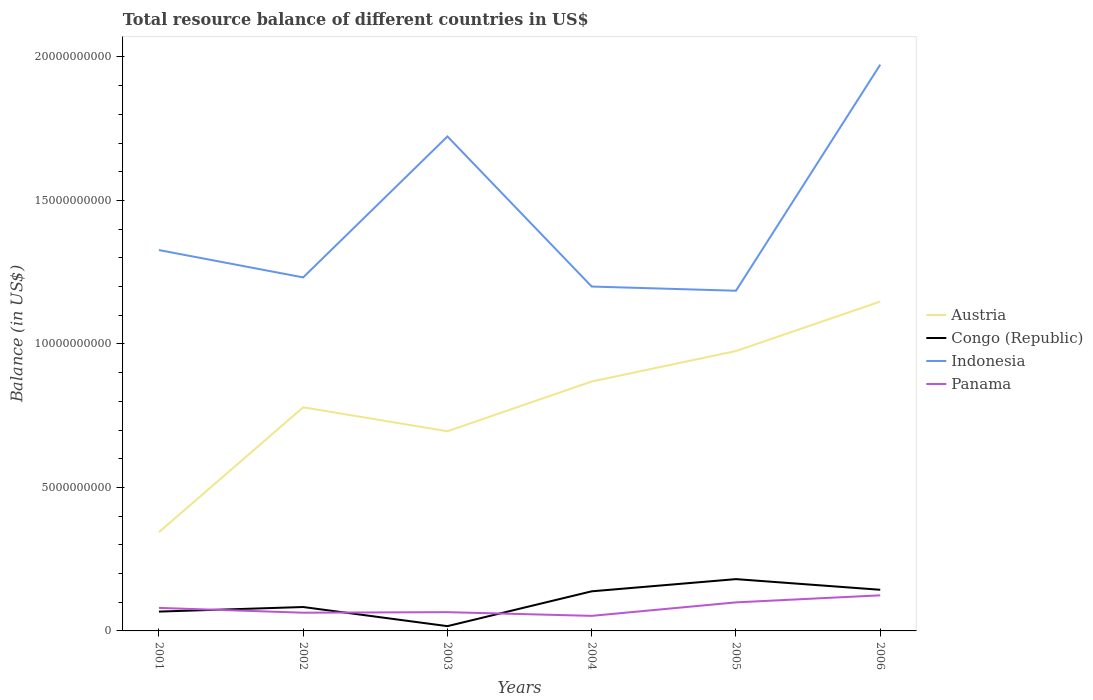Across all years, what is the maximum total resource balance in Austria?
Your answer should be very brief. 3.44e+09. In which year was the total resource balance in Austria maximum?
Your response must be concise. 2001. What is the total total resource balance in Indonesia in the graph?
Your response must be concise. -4.91e+09. What is the difference between the highest and the second highest total resource balance in Austria?
Provide a succinct answer. 8.04e+09. What is the difference between the highest and the lowest total resource balance in Congo (Republic)?
Provide a short and direct response. 3. Are the values on the major ticks of Y-axis written in scientific E-notation?
Your answer should be very brief. No. Does the graph contain any zero values?
Ensure brevity in your answer.  No. What is the title of the graph?
Your response must be concise. Total resource balance of different countries in US$. What is the label or title of the X-axis?
Your answer should be very brief. Years. What is the label or title of the Y-axis?
Give a very brief answer. Balance (in US$). What is the Balance (in US$) of Austria in 2001?
Keep it short and to the point. 3.44e+09. What is the Balance (in US$) in Congo (Republic) in 2001?
Provide a succinct answer. 6.74e+08. What is the Balance (in US$) in Indonesia in 2001?
Keep it short and to the point. 1.33e+1. What is the Balance (in US$) of Panama in 2001?
Make the answer very short. 8.03e+08. What is the Balance (in US$) in Austria in 2002?
Provide a succinct answer. 7.79e+09. What is the Balance (in US$) of Congo (Republic) in 2002?
Give a very brief answer. 8.33e+08. What is the Balance (in US$) in Indonesia in 2002?
Ensure brevity in your answer.  1.23e+1. What is the Balance (in US$) of Panama in 2002?
Ensure brevity in your answer.  6.35e+08. What is the Balance (in US$) in Austria in 2003?
Offer a very short reply. 6.96e+09. What is the Balance (in US$) of Congo (Republic) in 2003?
Your answer should be very brief. 1.67e+08. What is the Balance (in US$) of Indonesia in 2003?
Your answer should be compact. 1.72e+1. What is the Balance (in US$) in Panama in 2003?
Your answer should be very brief. 6.54e+08. What is the Balance (in US$) of Austria in 2004?
Keep it short and to the point. 8.69e+09. What is the Balance (in US$) of Congo (Republic) in 2004?
Provide a short and direct response. 1.38e+09. What is the Balance (in US$) of Indonesia in 2004?
Offer a terse response. 1.20e+1. What is the Balance (in US$) of Panama in 2004?
Your answer should be very brief. 5.25e+08. What is the Balance (in US$) in Austria in 2005?
Your answer should be compact. 9.75e+09. What is the Balance (in US$) of Congo (Republic) in 2005?
Your response must be concise. 1.80e+09. What is the Balance (in US$) of Indonesia in 2005?
Give a very brief answer. 1.19e+1. What is the Balance (in US$) in Panama in 2005?
Your answer should be very brief. 9.95e+08. What is the Balance (in US$) in Austria in 2006?
Your answer should be compact. 1.15e+1. What is the Balance (in US$) of Congo (Republic) in 2006?
Keep it short and to the point. 1.43e+09. What is the Balance (in US$) in Indonesia in 2006?
Provide a succinct answer. 1.97e+1. What is the Balance (in US$) in Panama in 2006?
Provide a short and direct response. 1.24e+09. Across all years, what is the maximum Balance (in US$) in Austria?
Your answer should be very brief. 1.15e+1. Across all years, what is the maximum Balance (in US$) in Congo (Republic)?
Give a very brief answer. 1.80e+09. Across all years, what is the maximum Balance (in US$) of Indonesia?
Provide a succinct answer. 1.97e+1. Across all years, what is the maximum Balance (in US$) of Panama?
Ensure brevity in your answer.  1.24e+09. Across all years, what is the minimum Balance (in US$) of Austria?
Your answer should be very brief. 3.44e+09. Across all years, what is the minimum Balance (in US$) of Congo (Republic)?
Provide a short and direct response. 1.67e+08. Across all years, what is the minimum Balance (in US$) of Indonesia?
Give a very brief answer. 1.19e+1. Across all years, what is the minimum Balance (in US$) in Panama?
Keep it short and to the point. 5.25e+08. What is the total Balance (in US$) of Austria in the graph?
Offer a very short reply. 4.81e+1. What is the total Balance (in US$) in Congo (Republic) in the graph?
Give a very brief answer. 6.29e+09. What is the total Balance (in US$) in Indonesia in the graph?
Your answer should be very brief. 8.64e+1. What is the total Balance (in US$) in Panama in the graph?
Make the answer very short. 4.85e+09. What is the difference between the Balance (in US$) of Austria in 2001 and that in 2002?
Provide a succinct answer. -4.35e+09. What is the difference between the Balance (in US$) in Congo (Republic) in 2001 and that in 2002?
Make the answer very short. -1.59e+08. What is the difference between the Balance (in US$) in Indonesia in 2001 and that in 2002?
Ensure brevity in your answer.  9.52e+08. What is the difference between the Balance (in US$) of Panama in 2001 and that in 2002?
Provide a succinct answer. 1.68e+08. What is the difference between the Balance (in US$) of Austria in 2001 and that in 2003?
Your answer should be very brief. -3.52e+09. What is the difference between the Balance (in US$) in Congo (Republic) in 2001 and that in 2003?
Give a very brief answer. 5.07e+08. What is the difference between the Balance (in US$) in Indonesia in 2001 and that in 2003?
Your answer should be very brief. -3.96e+09. What is the difference between the Balance (in US$) of Panama in 2001 and that in 2003?
Provide a succinct answer. 1.49e+08. What is the difference between the Balance (in US$) of Austria in 2001 and that in 2004?
Keep it short and to the point. -5.25e+09. What is the difference between the Balance (in US$) of Congo (Republic) in 2001 and that in 2004?
Give a very brief answer. -7.07e+08. What is the difference between the Balance (in US$) in Indonesia in 2001 and that in 2004?
Your response must be concise. 1.27e+09. What is the difference between the Balance (in US$) of Panama in 2001 and that in 2004?
Keep it short and to the point. 2.78e+08. What is the difference between the Balance (in US$) of Austria in 2001 and that in 2005?
Give a very brief answer. -6.31e+09. What is the difference between the Balance (in US$) in Congo (Republic) in 2001 and that in 2005?
Your answer should be compact. -1.13e+09. What is the difference between the Balance (in US$) of Indonesia in 2001 and that in 2005?
Provide a succinct answer. 1.42e+09. What is the difference between the Balance (in US$) in Panama in 2001 and that in 2005?
Your response must be concise. -1.92e+08. What is the difference between the Balance (in US$) in Austria in 2001 and that in 2006?
Your response must be concise. -8.04e+09. What is the difference between the Balance (in US$) in Congo (Republic) in 2001 and that in 2006?
Your answer should be very brief. -7.60e+08. What is the difference between the Balance (in US$) in Indonesia in 2001 and that in 2006?
Make the answer very short. -6.46e+09. What is the difference between the Balance (in US$) of Panama in 2001 and that in 2006?
Ensure brevity in your answer.  -4.38e+08. What is the difference between the Balance (in US$) of Austria in 2002 and that in 2003?
Make the answer very short. 8.34e+08. What is the difference between the Balance (in US$) of Congo (Republic) in 2002 and that in 2003?
Provide a short and direct response. 6.66e+08. What is the difference between the Balance (in US$) in Indonesia in 2002 and that in 2003?
Your answer should be very brief. -4.91e+09. What is the difference between the Balance (in US$) in Panama in 2002 and that in 2003?
Give a very brief answer. -1.88e+07. What is the difference between the Balance (in US$) in Austria in 2002 and that in 2004?
Your response must be concise. -8.99e+08. What is the difference between the Balance (in US$) of Congo (Republic) in 2002 and that in 2004?
Your answer should be compact. -5.47e+08. What is the difference between the Balance (in US$) in Indonesia in 2002 and that in 2004?
Give a very brief answer. 3.19e+08. What is the difference between the Balance (in US$) of Panama in 2002 and that in 2004?
Give a very brief answer. 1.10e+08. What is the difference between the Balance (in US$) of Austria in 2002 and that in 2005?
Make the answer very short. -1.96e+09. What is the difference between the Balance (in US$) of Congo (Republic) in 2002 and that in 2005?
Your answer should be very brief. -9.72e+08. What is the difference between the Balance (in US$) in Indonesia in 2002 and that in 2005?
Ensure brevity in your answer.  4.65e+08. What is the difference between the Balance (in US$) of Panama in 2002 and that in 2005?
Make the answer very short. -3.60e+08. What is the difference between the Balance (in US$) in Austria in 2002 and that in 2006?
Your response must be concise. -3.69e+09. What is the difference between the Balance (in US$) in Congo (Republic) in 2002 and that in 2006?
Your answer should be compact. -6.01e+08. What is the difference between the Balance (in US$) of Indonesia in 2002 and that in 2006?
Ensure brevity in your answer.  -7.41e+09. What is the difference between the Balance (in US$) of Panama in 2002 and that in 2006?
Your answer should be compact. -6.05e+08. What is the difference between the Balance (in US$) in Austria in 2003 and that in 2004?
Keep it short and to the point. -1.73e+09. What is the difference between the Balance (in US$) in Congo (Republic) in 2003 and that in 2004?
Your response must be concise. -1.21e+09. What is the difference between the Balance (in US$) of Indonesia in 2003 and that in 2004?
Give a very brief answer. 5.23e+09. What is the difference between the Balance (in US$) in Panama in 2003 and that in 2004?
Your answer should be very brief. 1.29e+08. What is the difference between the Balance (in US$) in Austria in 2003 and that in 2005?
Ensure brevity in your answer.  -2.80e+09. What is the difference between the Balance (in US$) in Congo (Republic) in 2003 and that in 2005?
Your answer should be compact. -1.64e+09. What is the difference between the Balance (in US$) in Indonesia in 2003 and that in 2005?
Your response must be concise. 5.38e+09. What is the difference between the Balance (in US$) in Panama in 2003 and that in 2005?
Provide a short and direct response. -3.41e+08. What is the difference between the Balance (in US$) in Austria in 2003 and that in 2006?
Ensure brevity in your answer.  -4.52e+09. What is the difference between the Balance (in US$) in Congo (Republic) in 2003 and that in 2006?
Your answer should be very brief. -1.27e+09. What is the difference between the Balance (in US$) of Indonesia in 2003 and that in 2006?
Give a very brief answer. -2.50e+09. What is the difference between the Balance (in US$) of Panama in 2003 and that in 2006?
Your answer should be very brief. -5.86e+08. What is the difference between the Balance (in US$) of Austria in 2004 and that in 2005?
Offer a terse response. -1.06e+09. What is the difference between the Balance (in US$) of Congo (Republic) in 2004 and that in 2005?
Offer a very short reply. -4.25e+08. What is the difference between the Balance (in US$) in Indonesia in 2004 and that in 2005?
Your response must be concise. 1.46e+08. What is the difference between the Balance (in US$) in Panama in 2004 and that in 2005?
Give a very brief answer. -4.70e+08. What is the difference between the Balance (in US$) in Austria in 2004 and that in 2006?
Your answer should be compact. -2.79e+09. What is the difference between the Balance (in US$) of Congo (Republic) in 2004 and that in 2006?
Your response must be concise. -5.31e+07. What is the difference between the Balance (in US$) of Indonesia in 2004 and that in 2006?
Offer a terse response. -7.73e+09. What is the difference between the Balance (in US$) of Panama in 2004 and that in 2006?
Make the answer very short. -7.15e+08. What is the difference between the Balance (in US$) in Austria in 2005 and that in 2006?
Your answer should be compact. -1.72e+09. What is the difference between the Balance (in US$) of Congo (Republic) in 2005 and that in 2006?
Offer a very short reply. 3.72e+08. What is the difference between the Balance (in US$) in Indonesia in 2005 and that in 2006?
Offer a very short reply. -7.88e+09. What is the difference between the Balance (in US$) in Panama in 2005 and that in 2006?
Your response must be concise. -2.46e+08. What is the difference between the Balance (in US$) in Austria in 2001 and the Balance (in US$) in Congo (Republic) in 2002?
Offer a terse response. 2.61e+09. What is the difference between the Balance (in US$) of Austria in 2001 and the Balance (in US$) of Indonesia in 2002?
Give a very brief answer. -8.88e+09. What is the difference between the Balance (in US$) of Austria in 2001 and the Balance (in US$) of Panama in 2002?
Provide a short and direct response. 2.81e+09. What is the difference between the Balance (in US$) in Congo (Republic) in 2001 and the Balance (in US$) in Indonesia in 2002?
Offer a very short reply. -1.16e+1. What is the difference between the Balance (in US$) of Congo (Republic) in 2001 and the Balance (in US$) of Panama in 2002?
Your response must be concise. 3.86e+07. What is the difference between the Balance (in US$) in Indonesia in 2001 and the Balance (in US$) in Panama in 2002?
Make the answer very short. 1.26e+1. What is the difference between the Balance (in US$) of Austria in 2001 and the Balance (in US$) of Congo (Republic) in 2003?
Offer a very short reply. 3.27e+09. What is the difference between the Balance (in US$) in Austria in 2001 and the Balance (in US$) in Indonesia in 2003?
Your response must be concise. -1.38e+1. What is the difference between the Balance (in US$) of Austria in 2001 and the Balance (in US$) of Panama in 2003?
Offer a very short reply. 2.79e+09. What is the difference between the Balance (in US$) in Congo (Republic) in 2001 and the Balance (in US$) in Indonesia in 2003?
Your response must be concise. -1.66e+1. What is the difference between the Balance (in US$) in Congo (Republic) in 2001 and the Balance (in US$) in Panama in 2003?
Offer a very short reply. 1.98e+07. What is the difference between the Balance (in US$) in Indonesia in 2001 and the Balance (in US$) in Panama in 2003?
Offer a terse response. 1.26e+1. What is the difference between the Balance (in US$) of Austria in 2001 and the Balance (in US$) of Congo (Republic) in 2004?
Ensure brevity in your answer.  2.06e+09. What is the difference between the Balance (in US$) of Austria in 2001 and the Balance (in US$) of Indonesia in 2004?
Your answer should be compact. -8.56e+09. What is the difference between the Balance (in US$) of Austria in 2001 and the Balance (in US$) of Panama in 2004?
Give a very brief answer. 2.92e+09. What is the difference between the Balance (in US$) in Congo (Republic) in 2001 and the Balance (in US$) in Indonesia in 2004?
Offer a terse response. -1.13e+1. What is the difference between the Balance (in US$) in Congo (Republic) in 2001 and the Balance (in US$) in Panama in 2004?
Your answer should be compact. 1.49e+08. What is the difference between the Balance (in US$) of Indonesia in 2001 and the Balance (in US$) of Panama in 2004?
Make the answer very short. 1.27e+1. What is the difference between the Balance (in US$) in Austria in 2001 and the Balance (in US$) in Congo (Republic) in 2005?
Make the answer very short. 1.64e+09. What is the difference between the Balance (in US$) in Austria in 2001 and the Balance (in US$) in Indonesia in 2005?
Your answer should be compact. -8.41e+09. What is the difference between the Balance (in US$) in Austria in 2001 and the Balance (in US$) in Panama in 2005?
Offer a very short reply. 2.45e+09. What is the difference between the Balance (in US$) in Congo (Republic) in 2001 and the Balance (in US$) in Indonesia in 2005?
Provide a succinct answer. -1.12e+1. What is the difference between the Balance (in US$) of Congo (Republic) in 2001 and the Balance (in US$) of Panama in 2005?
Offer a very short reply. -3.21e+08. What is the difference between the Balance (in US$) of Indonesia in 2001 and the Balance (in US$) of Panama in 2005?
Provide a short and direct response. 1.23e+1. What is the difference between the Balance (in US$) of Austria in 2001 and the Balance (in US$) of Congo (Republic) in 2006?
Keep it short and to the point. 2.01e+09. What is the difference between the Balance (in US$) in Austria in 2001 and the Balance (in US$) in Indonesia in 2006?
Ensure brevity in your answer.  -1.63e+1. What is the difference between the Balance (in US$) of Austria in 2001 and the Balance (in US$) of Panama in 2006?
Provide a short and direct response. 2.20e+09. What is the difference between the Balance (in US$) in Congo (Republic) in 2001 and the Balance (in US$) in Indonesia in 2006?
Ensure brevity in your answer.  -1.91e+1. What is the difference between the Balance (in US$) of Congo (Republic) in 2001 and the Balance (in US$) of Panama in 2006?
Your answer should be compact. -5.67e+08. What is the difference between the Balance (in US$) in Indonesia in 2001 and the Balance (in US$) in Panama in 2006?
Your answer should be very brief. 1.20e+1. What is the difference between the Balance (in US$) of Austria in 2002 and the Balance (in US$) of Congo (Republic) in 2003?
Provide a succinct answer. 7.63e+09. What is the difference between the Balance (in US$) in Austria in 2002 and the Balance (in US$) in Indonesia in 2003?
Provide a succinct answer. -9.44e+09. What is the difference between the Balance (in US$) of Austria in 2002 and the Balance (in US$) of Panama in 2003?
Offer a terse response. 7.14e+09. What is the difference between the Balance (in US$) of Congo (Republic) in 2002 and the Balance (in US$) of Indonesia in 2003?
Ensure brevity in your answer.  -1.64e+1. What is the difference between the Balance (in US$) in Congo (Republic) in 2002 and the Balance (in US$) in Panama in 2003?
Ensure brevity in your answer.  1.79e+08. What is the difference between the Balance (in US$) in Indonesia in 2002 and the Balance (in US$) in Panama in 2003?
Provide a succinct answer. 1.17e+1. What is the difference between the Balance (in US$) in Austria in 2002 and the Balance (in US$) in Congo (Republic) in 2004?
Give a very brief answer. 6.41e+09. What is the difference between the Balance (in US$) in Austria in 2002 and the Balance (in US$) in Indonesia in 2004?
Your response must be concise. -4.21e+09. What is the difference between the Balance (in US$) in Austria in 2002 and the Balance (in US$) in Panama in 2004?
Make the answer very short. 7.27e+09. What is the difference between the Balance (in US$) in Congo (Republic) in 2002 and the Balance (in US$) in Indonesia in 2004?
Ensure brevity in your answer.  -1.12e+1. What is the difference between the Balance (in US$) in Congo (Republic) in 2002 and the Balance (in US$) in Panama in 2004?
Your answer should be very brief. 3.08e+08. What is the difference between the Balance (in US$) in Indonesia in 2002 and the Balance (in US$) in Panama in 2004?
Your answer should be very brief. 1.18e+1. What is the difference between the Balance (in US$) in Austria in 2002 and the Balance (in US$) in Congo (Republic) in 2005?
Your answer should be very brief. 5.99e+09. What is the difference between the Balance (in US$) of Austria in 2002 and the Balance (in US$) of Indonesia in 2005?
Give a very brief answer. -4.06e+09. What is the difference between the Balance (in US$) in Austria in 2002 and the Balance (in US$) in Panama in 2005?
Offer a terse response. 6.80e+09. What is the difference between the Balance (in US$) in Congo (Republic) in 2002 and the Balance (in US$) in Indonesia in 2005?
Offer a very short reply. -1.10e+1. What is the difference between the Balance (in US$) of Congo (Republic) in 2002 and the Balance (in US$) of Panama in 2005?
Make the answer very short. -1.62e+08. What is the difference between the Balance (in US$) of Indonesia in 2002 and the Balance (in US$) of Panama in 2005?
Offer a very short reply. 1.13e+1. What is the difference between the Balance (in US$) in Austria in 2002 and the Balance (in US$) in Congo (Republic) in 2006?
Give a very brief answer. 6.36e+09. What is the difference between the Balance (in US$) of Austria in 2002 and the Balance (in US$) of Indonesia in 2006?
Ensure brevity in your answer.  -1.19e+1. What is the difference between the Balance (in US$) in Austria in 2002 and the Balance (in US$) in Panama in 2006?
Your response must be concise. 6.55e+09. What is the difference between the Balance (in US$) in Congo (Republic) in 2002 and the Balance (in US$) in Indonesia in 2006?
Provide a succinct answer. -1.89e+1. What is the difference between the Balance (in US$) in Congo (Republic) in 2002 and the Balance (in US$) in Panama in 2006?
Ensure brevity in your answer.  -4.07e+08. What is the difference between the Balance (in US$) in Indonesia in 2002 and the Balance (in US$) in Panama in 2006?
Provide a succinct answer. 1.11e+1. What is the difference between the Balance (in US$) of Austria in 2003 and the Balance (in US$) of Congo (Republic) in 2004?
Your answer should be very brief. 5.58e+09. What is the difference between the Balance (in US$) in Austria in 2003 and the Balance (in US$) in Indonesia in 2004?
Offer a very short reply. -5.04e+09. What is the difference between the Balance (in US$) in Austria in 2003 and the Balance (in US$) in Panama in 2004?
Offer a very short reply. 6.43e+09. What is the difference between the Balance (in US$) of Congo (Republic) in 2003 and the Balance (in US$) of Indonesia in 2004?
Offer a very short reply. -1.18e+1. What is the difference between the Balance (in US$) in Congo (Republic) in 2003 and the Balance (in US$) in Panama in 2004?
Keep it short and to the point. -3.58e+08. What is the difference between the Balance (in US$) of Indonesia in 2003 and the Balance (in US$) of Panama in 2004?
Keep it short and to the point. 1.67e+1. What is the difference between the Balance (in US$) of Austria in 2003 and the Balance (in US$) of Congo (Republic) in 2005?
Offer a terse response. 5.15e+09. What is the difference between the Balance (in US$) in Austria in 2003 and the Balance (in US$) in Indonesia in 2005?
Your answer should be very brief. -4.90e+09. What is the difference between the Balance (in US$) of Austria in 2003 and the Balance (in US$) of Panama in 2005?
Provide a short and direct response. 5.96e+09. What is the difference between the Balance (in US$) in Congo (Republic) in 2003 and the Balance (in US$) in Indonesia in 2005?
Your response must be concise. -1.17e+1. What is the difference between the Balance (in US$) in Congo (Republic) in 2003 and the Balance (in US$) in Panama in 2005?
Make the answer very short. -8.28e+08. What is the difference between the Balance (in US$) of Indonesia in 2003 and the Balance (in US$) of Panama in 2005?
Your response must be concise. 1.62e+1. What is the difference between the Balance (in US$) in Austria in 2003 and the Balance (in US$) in Congo (Republic) in 2006?
Provide a succinct answer. 5.52e+09. What is the difference between the Balance (in US$) in Austria in 2003 and the Balance (in US$) in Indonesia in 2006?
Your answer should be compact. -1.28e+1. What is the difference between the Balance (in US$) of Austria in 2003 and the Balance (in US$) of Panama in 2006?
Your answer should be compact. 5.72e+09. What is the difference between the Balance (in US$) in Congo (Republic) in 2003 and the Balance (in US$) in Indonesia in 2006?
Ensure brevity in your answer.  -1.96e+1. What is the difference between the Balance (in US$) of Congo (Republic) in 2003 and the Balance (in US$) of Panama in 2006?
Provide a succinct answer. -1.07e+09. What is the difference between the Balance (in US$) of Indonesia in 2003 and the Balance (in US$) of Panama in 2006?
Your response must be concise. 1.60e+1. What is the difference between the Balance (in US$) of Austria in 2004 and the Balance (in US$) of Congo (Republic) in 2005?
Make the answer very short. 6.89e+09. What is the difference between the Balance (in US$) of Austria in 2004 and the Balance (in US$) of Indonesia in 2005?
Provide a succinct answer. -3.16e+09. What is the difference between the Balance (in US$) of Austria in 2004 and the Balance (in US$) of Panama in 2005?
Offer a terse response. 7.70e+09. What is the difference between the Balance (in US$) of Congo (Republic) in 2004 and the Balance (in US$) of Indonesia in 2005?
Provide a short and direct response. -1.05e+1. What is the difference between the Balance (in US$) of Congo (Republic) in 2004 and the Balance (in US$) of Panama in 2005?
Your answer should be compact. 3.86e+08. What is the difference between the Balance (in US$) of Indonesia in 2004 and the Balance (in US$) of Panama in 2005?
Offer a very short reply. 1.10e+1. What is the difference between the Balance (in US$) in Austria in 2004 and the Balance (in US$) in Congo (Republic) in 2006?
Keep it short and to the point. 7.26e+09. What is the difference between the Balance (in US$) of Austria in 2004 and the Balance (in US$) of Indonesia in 2006?
Make the answer very short. -1.10e+1. What is the difference between the Balance (in US$) of Austria in 2004 and the Balance (in US$) of Panama in 2006?
Provide a short and direct response. 7.45e+09. What is the difference between the Balance (in US$) of Congo (Republic) in 2004 and the Balance (in US$) of Indonesia in 2006?
Give a very brief answer. -1.84e+1. What is the difference between the Balance (in US$) in Congo (Republic) in 2004 and the Balance (in US$) in Panama in 2006?
Provide a succinct answer. 1.40e+08. What is the difference between the Balance (in US$) of Indonesia in 2004 and the Balance (in US$) of Panama in 2006?
Provide a short and direct response. 1.08e+1. What is the difference between the Balance (in US$) of Austria in 2005 and the Balance (in US$) of Congo (Republic) in 2006?
Make the answer very short. 8.32e+09. What is the difference between the Balance (in US$) of Austria in 2005 and the Balance (in US$) of Indonesia in 2006?
Your answer should be compact. -9.98e+09. What is the difference between the Balance (in US$) in Austria in 2005 and the Balance (in US$) in Panama in 2006?
Keep it short and to the point. 8.51e+09. What is the difference between the Balance (in US$) of Congo (Republic) in 2005 and the Balance (in US$) of Indonesia in 2006?
Give a very brief answer. -1.79e+1. What is the difference between the Balance (in US$) of Congo (Republic) in 2005 and the Balance (in US$) of Panama in 2006?
Ensure brevity in your answer.  5.65e+08. What is the difference between the Balance (in US$) in Indonesia in 2005 and the Balance (in US$) in Panama in 2006?
Your response must be concise. 1.06e+1. What is the average Balance (in US$) in Austria per year?
Your answer should be compact. 8.02e+09. What is the average Balance (in US$) in Congo (Republic) per year?
Your answer should be very brief. 1.05e+09. What is the average Balance (in US$) in Indonesia per year?
Ensure brevity in your answer.  1.44e+1. What is the average Balance (in US$) in Panama per year?
Your answer should be compact. 8.09e+08. In the year 2001, what is the difference between the Balance (in US$) in Austria and Balance (in US$) in Congo (Republic)?
Ensure brevity in your answer.  2.77e+09. In the year 2001, what is the difference between the Balance (in US$) of Austria and Balance (in US$) of Indonesia?
Ensure brevity in your answer.  -9.83e+09. In the year 2001, what is the difference between the Balance (in US$) of Austria and Balance (in US$) of Panama?
Your answer should be very brief. 2.64e+09. In the year 2001, what is the difference between the Balance (in US$) in Congo (Republic) and Balance (in US$) in Indonesia?
Your response must be concise. -1.26e+1. In the year 2001, what is the difference between the Balance (in US$) of Congo (Republic) and Balance (in US$) of Panama?
Ensure brevity in your answer.  -1.29e+08. In the year 2001, what is the difference between the Balance (in US$) of Indonesia and Balance (in US$) of Panama?
Offer a terse response. 1.25e+1. In the year 2002, what is the difference between the Balance (in US$) in Austria and Balance (in US$) in Congo (Republic)?
Offer a very short reply. 6.96e+09. In the year 2002, what is the difference between the Balance (in US$) in Austria and Balance (in US$) in Indonesia?
Make the answer very short. -4.53e+09. In the year 2002, what is the difference between the Balance (in US$) of Austria and Balance (in US$) of Panama?
Your answer should be compact. 7.16e+09. In the year 2002, what is the difference between the Balance (in US$) of Congo (Republic) and Balance (in US$) of Indonesia?
Keep it short and to the point. -1.15e+1. In the year 2002, what is the difference between the Balance (in US$) in Congo (Republic) and Balance (in US$) in Panama?
Give a very brief answer. 1.98e+08. In the year 2002, what is the difference between the Balance (in US$) in Indonesia and Balance (in US$) in Panama?
Offer a terse response. 1.17e+1. In the year 2003, what is the difference between the Balance (in US$) of Austria and Balance (in US$) of Congo (Republic)?
Offer a very short reply. 6.79e+09. In the year 2003, what is the difference between the Balance (in US$) in Austria and Balance (in US$) in Indonesia?
Give a very brief answer. -1.03e+1. In the year 2003, what is the difference between the Balance (in US$) of Austria and Balance (in US$) of Panama?
Give a very brief answer. 6.30e+09. In the year 2003, what is the difference between the Balance (in US$) in Congo (Republic) and Balance (in US$) in Indonesia?
Ensure brevity in your answer.  -1.71e+1. In the year 2003, what is the difference between the Balance (in US$) in Congo (Republic) and Balance (in US$) in Panama?
Ensure brevity in your answer.  -4.87e+08. In the year 2003, what is the difference between the Balance (in US$) in Indonesia and Balance (in US$) in Panama?
Offer a very short reply. 1.66e+1. In the year 2004, what is the difference between the Balance (in US$) in Austria and Balance (in US$) in Congo (Republic)?
Give a very brief answer. 7.31e+09. In the year 2004, what is the difference between the Balance (in US$) in Austria and Balance (in US$) in Indonesia?
Offer a very short reply. -3.31e+09. In the year 2004, what is the difference between the Balance (in US$) in Austria and Balance (in US$) in Panama?
Offer a terse response. 8.17e+09. In the year 2004, what is the difference between the Balance (in US$) in Congo (Republic) and Balance (in US$) in Indonesia?
Give a very brief answer. -1.06e+1. In the year 2004, what is the difference between the Balance (in US$) in Congo (Republic) and Balance (in US$) in Panama?
Offer a very short reply. 8.55e+08. In the year 2004, what is the difference between the Balance (in US$) in Indonesia and Balance (in US$) in Panama?
Offer a very short reply. 1.15e+1. In the year 2005, what is the difference between the Balance (in US$) in Austria and Balance (in US$) in Congo (Republic)?
Offer a very short reply. 7.95e+09. In the year 2005, what is the difference between the Balance (in US$) of Austria and Balance (in US$) of Indonesia?
Your response must be concise. -2.10e+09. In the year 2005, what is the difference between the Balance (in US$) of Austria and Balance (in US$) of Panama?
Your response must be concise. 8.76e+09. In the year 2005, what is the difference between the Balance (in US$) in Congo (Republic) and Balance (in US$) in Indonesia?
Ensure brevity in your answer.  -1.00e+1. In the year 2005, what is the difference between the Balance (in US$) in Congo (Republic) and Balance (in US$) in Panama?
Ensure brevity in your answer.  8.10e+08. In the year 2005, what is the difference between the Balance (in US$) in Indonesia and Balance (in US$) in Panama?
Provide a succinct answer. 1.09e+1. In the year 2006, what is the difference between the Balance (in US$) of Austria and Balance (in US$) of Congo (Republic)?
Provide a short and direct response. 1.00e+1. In the year 2006, what is the difference between the Balance (in US$) of Austria and Balance (in US$) of Indonesia?
Provide a short and direct response. -8.25e+09. In the year 2006, what is the difference between the Balance (in US$) in Austria and Balance (in US$) in Panama?
Your response must be concise. 1.02e+1. In the year 2006, what is the difference between the Balance (in US$) in Congo (Republic) and Balance (in US$) in Indonesia?
Keep it short and to the point. -1.83e+1. In the year 2006, what is the difference between the Balance (in US$) in Congo (Republic) and Balance (in US$) in Panama?
Provide a succinct answer. 1.93e+08. In the year 2006, what is the difference between the Balance (in US$) in Indonesia and Balance (in US$) in Panama?
Your answer should be very brief. 1.85e+1. What is the ratio of the Balance (in US$) of Austria in 2001 to that in 2002?
Keep it short and to the point. 0.44. What is the ratio of the Balance (in US$) in Congo (Republic) in 2001 to that in 2002?
Keep it short and to the point. 0.81. What is the ratio of the Balance (in US$) of Indonesia in 2001 to that in 2002?
Give a very brief answer. 1.08. What is the ratio of the Balance (in US$) of Panama in 2001 to that in 2002?
Provide a succinct answer. 1.26. What is the ratio of the Balance (in US$) in Austria in 2001 to that in 2003?
Offer a very short reply. 0.49. What is the ratio of the Balance (in US$) of Congo (Republic) in 2001 to that in 2003?
Provide a short and direct response. 4.05. What is the ratio of the Balance (in US$) in Indonesia in 2001 to that in 2003?
Offer a very short reply. 0.77. What is the ratio of the Balance (in US$) of Panama in 2001 to that in 2003?
Give a very brief answer. 1.23. What is the ratio of the Balance (in US$) of Austria in 2001 to that in 2004?
Your response must be concise. 0.4. What is the ratio of the Balance (in US$) in Congo (Republic) in 2001 to that in 2004?
Ensure brevity in your answer.  0.49. What is the ratio of the Balance (in US$) of Indonesia in 2001 to that in 2004?
Keep it short and to the point. 1.11. What is the ratio of the Balance (in US$) of Panama in 2001 to that in 2004?
Make the answer very short. 1.53. What is the ratio of the Balance (in US$) of Austria in 2001 to that in 2005?
Your answer should be compact. 0.35. What is the ratio of the Balance (in US$) of Congo (Republic) in 2001 to that in 2005?
Give a very brief answer. 0.37. What is the ratio of the Balance (in US$) of Indonesia in 2001 to that in 2005?
Your answer should be compact. 1.12. What is the ratio of the Balance (in US$) in Panama in 2001 to that in 2005?
Provide a succinct answer. 0.81. What is the ratio of the Balance (in US$) of Austria in 2001 to that in 2006?
Your response must be concise. 0.3. What is the ratio of the Balance (in US$) of Congo (Republic) in 2001 to that in 2006?
Make the answer very short. 0.47. What is the ratio of the Balance (in US$) of Indonesia in 2001 to that in 2006?
Offer a very short reply. 0.67. What is the ratio of the Balance (in US$) in Panama in 2001 to that in 2006?
Keep it short and to the point. 0.65. What is the ratio of the Balance (in US$) of Austria in 2002 to that in 2003?
Your response must be concise. 1.12. What is the ratio of the Balance (in US$) in Congo (Republic) in 2002 to that in 2003?
Offer a terse response. 5. What is the ratio of the Balance (in US$) of Indonesia in 2002 to that in 2003?
Offer a very short reply. 0.71. What is the ratio of the Balance (in US$) in Panama in 2002 to that in 2003?
Make the answer very short. 0.97. What is the ratio of the Balance (in US$) in Austria in 2002 to that in 2004?
Give a very brief answer. 0.9. What is the ratio of the Balance (in US$) of Congo (Republic) in 2002 to that in 2004?
Offer a very short reply. 0.6. What is the ratio of the Balance (in US$) of Indonesia in 2002 to that in 2004?
Make the answer very short. 1.03. What is the ratio of the Balance (in US$) of Panama in 2002 to that in 2004?
Your answer should be compact. 1.21. What is the ratio of the Balance (in US$) in Austria in 2002 to that in 2005?
Provide a short and direct response. 0.8. What is the ratio of the Balance (in US$) in Congo (Republic) in 2002 to that in 2005?
Your answer should be compact. 0.46. What is the ratio of the Balance (in US$) in Indonesia in 2002 to that in 2005?
Offer a very short reply. 1.04. What is the ratio of the Balance (in US$) of Panama in 2002 to that in 2005?
Your response must be concise. 0.64. What is the ratio of the Balance (in US$) of Austria in 2002 to that in 2006?
Your response must be concise. 0.68. What is the ratio of the Balance (in US$) of Congo (Republic) in 2002 to that in 2006?
Keep it short and to the point. 0.58. What is the ratio of the Balance (in US$) of Indonesia in 2002 to that in 2006?
Keep it short and to the point. 0.62. What is the ratio of the Balance (in US$) in Panama in 2002 to that in 2006?
Ensure brevity in your answer.  0.51. What is the ratio of the Balance (in US$) in Austria in 2003 to that in 2004?
Ensure brevity in your answer.  0.8. What is the ratio of the Balance (in US$) in Congo (Republic) in 2003 to that in 2004?
Your response must be concise. 0.12. What is the ratio of the Balance (in US$) of Indonesia in 2003 to that in 2004?
Provide a succinct answer. 1.44. What is the ratio of the Balance (in US$) of Panama in 2003 to that in 2004?
Offer a very short reply. 1.25. What is the ratio of the Balance (in US$) in Austria in 2003 to that in 2005?
Your response must be concise. 0.71. What is the ratio of the Balance (in US$) of Congo (Republic) in 2003 to that in 2005?
Make the answer very short. 0.09. What is the ratio of the Balance (in US$) in Indonesia in 2003 to that in 2005?
Provide a short and direct response. 1.45. What is the ratio of the Balance (in US$) in Panama in 2003 to that in 2005?
Give a very brief answer. 0.66. What is the ratio of the Balance (in US$) in Austria in 2003 to that in 2006?
Provide a succinct answer. 0.61. What is the ratio of the Balance (in US$) of Congo (Republic) in 2003 to that in 2006?
Offer a terse response. 0.12. What is the ratio of the Balance (in US$) in Indonesia in 2003 to that in 2006?
Make the answer very short. 0.87. What is the ratio of the Balance (in US$) in Panama in 2003 to that in 2006?
Ensure brevity in your answer.  0.53. What is the ratio of the Balance (in US$) of Austria in 2004 to that in 2005?
Provide a short and direct response. 0.89. What is the ratio of the Balance (in US$) in Congo (Republic) in 2004 to that in 2005?
Your response must be concise. 0.76. What is the ratio of the Balance (in US$) in Indonesia in 2004 to that in 2005?
Your answer should be very brief. 1.01. What is the ratio of the Balance (in US$) in Panama in 2004 to that in 2005?
Keep it short and to the point. 0.53. What is the ratio of the Balance (in US$) of Austria in 2004 to that in 2006?
Ensure brevity in your answer.  0.76. What is the ratio of the Balance (in US$) in Congo (Republic) in 2004 to that in 2006?
Ensure brevity in your answer.  0.96. What is the ratio of the Balance (in US$) in Indonesia in 2004 to that in 2006?
Offer a very short reply. 0.61. What is the ratio of the Balance (in US$) in Panama in 2004 to that in 2006?
Ensure brevity in your answer.  0.42. What is the ratio of the Balance (in US$) in Austria in 2005 to that in 2006?
Make the answer very short. 0.85. What is the ratio of the Balance (in US$) of Congo (Republic) in 2005 to that in 2006?
Keep it short and to the point. 1.26. What is the ratio of the Balance (in US$) of Indonesia in 2005 to that in 2006?
Your answer should be very brief. 0.6. What is the ratio of the Balance (in US$) in Panama in 2005 to that in 2006?
Provide a short and direct response. 0.8. What is the difference between the highest and the second highest Balance (in US$) of Austria?
Your answer should be compact. 1.72e+09. What is the difference between the highest and the second highest Balance (in US$) of Congo (Republic)?
Keep it short and to the point. 3.72e+08. What is the difference between the highest and the second highest Balance (in US$) of Indonesia?
Make the answer very short. 2.50e+09. What is the difference between the highest and the second highest Balance (in US$) in Panama?
Ensure brevity in your answer.  2.46e+08. What is the difference between the highest and the lowest Balance (in US$) of Austria?
Your response must be concise. 8.04e+09. What is the difference between the highest and the lowest Balance (in US$) of Congo (Republic)?
Provide a short and direct response. 1.64e+09. What is the difference between the highest and the lowest Balance (in US$) in Indonesia?
Your answer should be very brief. 7.88e+09. What is the difference between the highest and the lowest Balance (in US$) in Panama?
Your answer should be very brief. 7.15e+08. 